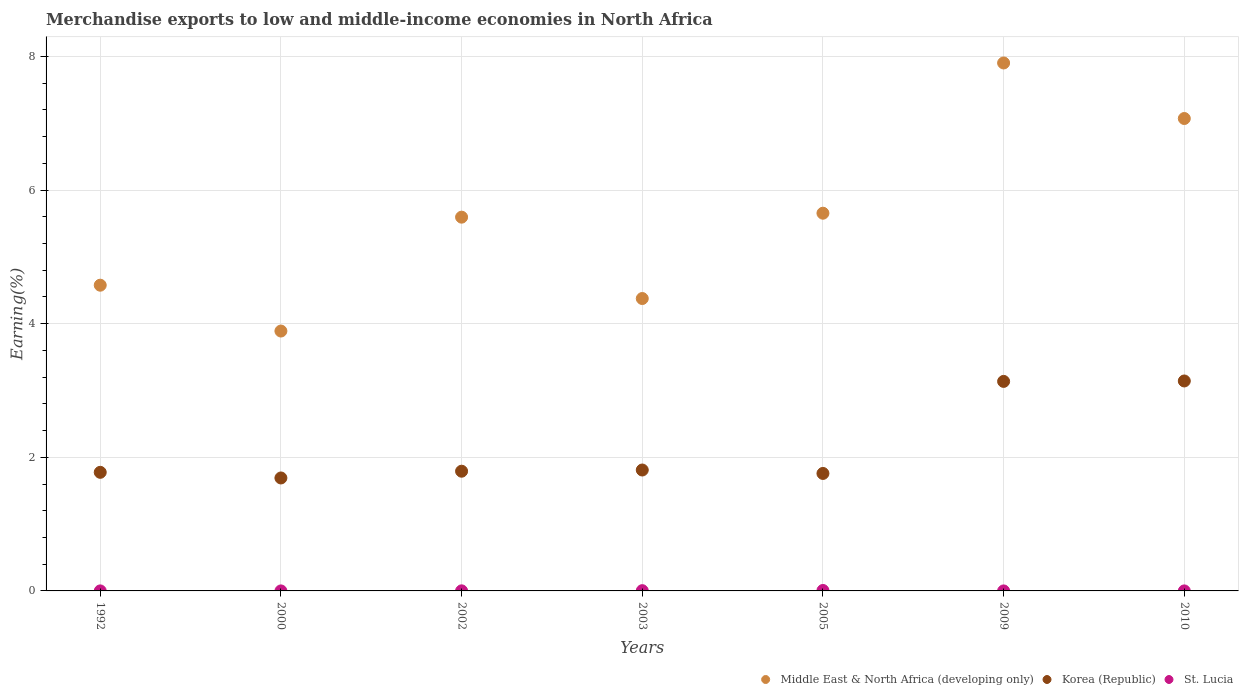What is the percentage of amount earned from merchandise exports in Korea (Republic) in 2005?
Provide a succinct answer. 1.76. Across all years, what is the maximum percentage of amount earned from merchandise exports in Middle East & North Africa (developing only)?
Provide a short and direct response. 7.9. Across all years, what is the minimum percentage of amount earned from merchandise exports in St. Lucia?
Your answer should be compact. 4.81975497009493e-5. In which year was the percentage of amount earned from merchandise exports in Korea (Republic) minimum?
Your answer should be compact. 2000. What is the total percentage of amount earned from merchandise exports in St. Lucia in the graph?
Keep it short and to the point. 0.01. What is the difference between the percentage of amount earned from merchandise exports in Korea (Republic) in 1992 and that in 2002?
Your answer should be compact. -0.02. What is the difference between the percentage of amount earned from merchandise exports in Korea (Republic) in 2002 and the percentage of amount earned from merchandise exports in Middle East & North Africa (developing only) in 2003?
Provide a succinct answer. -2.58. What is the average percentage of amount earned from merchandise exports in St. Lucia per year?
Keep it short and to the point. 0. In the year 2002, what is the difference between the percentage of amount earned from merchandise exports in St. Lucia and percentage of amount earned from merchandise exports in Korea (Republic)?
Your response must be concise. -1.79. What is the ratio of the percentage of amount earned from merchandise exports in Korea (Republic) in 2005 to that in 2009?
Offer a terse response. 0.56. Is the difference between the percentage of amount earned from merchandise exports in St. Lucia in 2003 and 2010 greater than the difference between the percentage of amount earned from merchandise exports in Korea (Republic) in 2003 and 2010?
Make the answer very short. Yes. What is the difference between the highest and the second highest percentage of amount earned from merchandise exports in Middle East & North Africa (developing only)?
Your answer should be compact. 0.83. What is the difference between the highest and the lowest percentage of amount earned from merchandise exports in Korea (Republic)?
Your answer should be very brief. 1.45. Is it the case that in every year, the sum of the percentage of amount earned from merchandise exports in Korea (Republic) and percentage of amount earned from merchandise exports in St. Lucia  is greater than the percentage of amount earned from merchandise exports in Middle East & North Africa (developing only)?
Keep it short and to the point. No. Does the percentage of amount earned from merchandise exports in St. Lucia monotonically increase over the years?
Your response must be concise. No. Is the percentage of amount earned from merchandise exports in Korea (Republic) strictly greater than the percentage of amount earned from merchandise exports in Middle East & North Africa (developing only) over the years?
Provide a succinct answer. No. How many dotlines are there?
Ensure brevity in your answer.  3. What is the difference between two consecutive major ticks on the Y-axis?
Your answer should be very brief. 2. Are the values on the major ticks of Y-axis written in scientific E-notation?
Give a very brief answer. No. What is the title of the graph?
Offer a very short reply. Merchandise exports to low and middle-income economies in North Africa. What is the label or title of the X-axis?
Make the answer very short. Years. What is the label or title of the Y-axis?
Your answer should be compact. Earning(%). What is the Earning(%) of Middle East & North Africa (developing only) in 1992?
Keep it short and to the point. 4.58. What is the Earning(%) in Korea (Republic) in 1992?
Your answer should be very brief. 1.78. What is the Earning(%) in St. Lucia in 1992?
Ensure brevity in your answer.  0. What is the Earning(%) in Middle East & North Africa (developing only) in 2000?
Make the answer very short. 3.89. What is the Earning(%) in Korea (Republic) in 2000?
Provide a short and direct response. 1.69. What is the Earning(%) of St. Lucia in 2000?
Keep it short and to the point. 0. What is the Earning(%) in Middle East & North Africa (developing only) in 2002?
Your answer should be compact. 5.59. What is the Earning(%) in Korea (Republic) in 2002?
Offer a very short reply. 1.79. What is the Earning(%) of St. Lucia in 2002?
Give a very brief answer. 0. What is the Earning(%) in Middle East & North Africa (developing only) in 2003?
Your answer should be compact. 4.38. What is the Earning(%) in Korea (Republic) in 2003?
Your answer should be compact. 1.81. What is the Earning(%) of St. Lucia in 2003?
Offer a very short reply. 0. What is the Earning(%) of Middle East & North Africa (developing only) in 2005?
Your answer should be compact. 5.65. What is the Earning(%) of Korea (Republic) in 2005?
Give a very brief answer. 1.76. What is the Earning(%) of St. Lucia in 2005?
Offer a terse response. 0.01. What is the Earning(%) of Middle East & North Africa (developing only) in 2009?
Your answer should be very brief. 7.9. What is the Earning(%) in Korea (Republic) in 2009?
Keep it short and to the point. 3.14. What is the Earning(%) in St. Lucia in 2009?
Offer a very short reply. 4.81975497009493e-5. What is the Earning(%) in Middle East & North Africa (developing only) in 2010?
Provide a short and direct response. 7.07. What is the Earning(%) of Korea (Republic) in 2010?
Your answer should be very brief. 3.14. What is the Earning(%) of St. Lucia in 2010?
Provide a succinct answer. 0. Across all years, what is the maximum Earning(%) in Middle East & North Africa (developing only)?
Make the answer very short. 7.9. Across all years, what is the maximum Earning(%) in Korea (Republic)?
Your answer should be compact. 3.14. Across all years, what is the maximum Earning(%) in St. Lucia?
Make the answer very short. 0.01. Across all years, what is the minimum Earning(%) of Middle East & North Africa (developing only)?
Provide a short and direct response. 3.89. Across all years, what is the minimum Earning(%) of Korea (Republic)?
Ensure brevity in your answer.  1.69. Across all years, what is the minimum Earning(%) of St. Lucia?
Provide a short and direct response. 4.81975497009493e-5. What is the total Earning(%) in Middle East & North Africa (developing only) in the graph?
Your response must be concise. 39.06. What is the total Earning(%) of Korea (Republic) in the graph?
Offer a very short reply. 15.1. What is the total Earning(%) of St. Lucia in the graph?
Your response must be concise. 0.01. What is the difference between the Earning(%) of Middle East & North Africa (developing only) in 1992 and that in 2000?
Keep it short and to the point. 0.69. What is the difference between the Earning(%) of Korea (Republic) in 1992 and that in 2000?
Provide a short and direct response. 0.08. What is the difference between the Earning(%) of Middle East & North Africa (developing only) in 1992 and that in 2002?
Your answer should be compact. -1.02. What is the difference between the Earning(%) of Korea (Republic) in 1992 and that in 2002?
Provide a succinct answer. -0.02. What is the difference between the Earning(%) in St. Lucia in 1992 and that in 2002?
Provide a short and direct response. -0. What is the difference between the Earning(%) of Middle East & North Africa (developing only) in 1992 and that in 2003?
Keep it short and to the point. 0.2. What is the difference between the Earning(%) in Korea (Republic) in 1992 and that in 2003?
Give a very brief answer. -0.03. What is the difference between the Earning(%) of St. Lucia in 1992 and that in 2003?
Your response must be concise. -0. What is the difference between the Earning(%) in Middle East & North Africa (developing only) in 1992 and that in 2005?
Your answer should be compact. -1.08. What is the difference between the Earning(%) in Korea (Republic) in 1992 and that in 2005?
Provide a short and direct response. 0.02. What is the difference between the Earning(%) in St. Lucia in 1992 and that in 2005?
Make the answer very short. -0.01. What is the difference between the Earning(%) of Middle East & North Africa (developing only) in 1992 and that in 2009?
Keep it short and to the point. -3.33. What is the difference between the Earning(%) in Korea (Republic) in 1992 and that in 2009?
Keep it short and to the point. -1.36. What is the difference between the Earning(%) of St. Lucia in 1992 and that in 2009?
Make the answer very short. 0. What is the difference between the Earning(%) in Middle East & North Africa (developing only) in 1992 and that in 2010?
Your answer should be compact. -2.5. What is the difference between the Earning(%) in Korea (Republic) in 1992 and that in 2010?
Your answer should be compact. -1.37. What is the difference between the Earning(%) in St. Lucia in 1992 and that in 2010?
Your answer should be very brief. 0. What is the difference between the Earning(%) of Middle East & North Africa (developing only) in 2000 and that in 2002?
Provide a short and direct response. -1.7. What is the difference between the Earning(%) in Korea (Republic) in 2000 and that in 2002?
Provide a short and direct response. -0.1. What is the difference between the Earning(%) of St. Lucia in 2000 and that in 2002?
Give a very brief answer. -0. What is the difference between the Earning(%) in Middle East & North Africa (developing only) in 2000 and that in 2003?
Offer a very short reply. -0.49. What is the difference between the Earning(%) in Korea (Republic) in 2000 and that in 2003?
Your answer should be very brief. -0.12. What is the difference between the Earning(%) in St. Lucia in 2000 and that in 2003?
Keep it short and to the point. -0. What is the difference between the Earning(%) of Middle East & North Africa (developing only) in 2000 and that in 2005?
Ensure brevity in your answer.  -1.76. What is the difference between the Earning(%) of Korea (Republic) in 2000 and that in 2005?
Provide a succinct answer. -0.07. What is the difference between the Earning(%) of St. Lucia in 2000 and that in 2005?
Your answer should be very brief. -0.01. What is the difference between the Earning(%) of Middle East & North Africa (developing only) in 2000 and that in 2009?
Give a very brief answer. -4.01. What is the difference between the Earning(%) in Korea (Republic) in 2000 and that in 2009?
Your answer should be very brief. -1.45. What is the difference between the Earning(%) of St. Lucia in 2000 and that in 2009?
Give a very brief answer. 0. What is the difference between the Earning(%) of Middle East & North Africa (developing only) in 2000 and that in 2010?
Offer a very short reply. -3.18. What is the difference between the Earning(%) of Korea (Republic) in 2000 and that in 2010?
Provide a succinct answer. -1.45. What is the difference between the Earning(%) of St. Lucia in 2000 and that in 2010?
Make the answer very short. -0. What is the difference between the Earning(%) in Middle East & North Africa (developing only) in 2002 and that in 2003?
Offer a terse response. 1.22. What is the difference between the Earning(%) in Korea (Republic) in 2002 and that in 2003?
Your answer should be very brief. -0.02. What is the difference between the Earning(%) in St. Lucia in 2002 and that in 2003?
Keep it short and to the point. -0. What is the difference between the Earning(%) in Middle East & North Africa (developing only) in 2002 and that in 2005?
Ensure brevity in your answer.  -0.06. What is the difference between the Earning(%) of Korea (Republic) in 2002 and that in 2005?
Your response must be concise. 0.03. What is the difference between the Earning(%) in St. Lucia in 2002 and that in 2005?
Your answer should be compact. -0.01. What is the difference between the Earning(%) of Middle East & North Africa (developing only) in 2002 and that in 2009?
Provide a succinct answer. -2.31. What is the difference between the Earning(%) in Korea (Republic) in 2002 and that in 2009?
Your response must be concise. -1.34. What is the difference between the Earning(%) of St. Lucia in 2002 and that in 2009?
Your answer should be very brief. 0. What is the difference between the Earning(%) in Middle East & North Africa (developing only) in 2002 and that in 2010?
Offer a terse response. -1.48. What is the difference between the Earning(%) of Korea (Republic) in 2002 and that in 2010?
Give a very brief answer. -1.35. What is the difference between the Earning(%) in Middle East & North Africa (developing only) in 2003 and that in 2005?
Provide a succinct answer. -1.28. What is the difference between the Earning(%) of Korea (Republic) in 2003 and that in 2005?
Provide a short and direct response. 0.05. What is the difference between the Earning(%) in St. Lucia in 2003 and that in 2005?
Your answer should be very brief. -0. What is the difference between the Earning(%) in Middle East & North Africa (developing only) in 2003 and that in 2009?
Provide a short and direct response. -3.53. What is the difference between the Earning(%) in Korea (Republic) in 2003 and that in 2009?
Provide a succinct answer. -1.33. What is the difference between the Earning(%) in St. Lucia in 2003 and that in 2009?
Provide a succinct answer. 0. What is the difference between the Earning(%) of Middle East & North Africa (developing only) in 2003 and that in 2010?
Offer a terse response. -2.69. What is the difference between the Earning(%) of Korea (Republic) in 2003 and that in 2010?
Your answer should be compact. -1.33. What is the difference between the Earning(%) of St. Lucia in 2003 and that in 2010?
Make the answer very short. 0. What is the difference between the Earning(%) in Middle East & North Africa (developing only) in 2005 and that in 2009?
Keep it short and to the point. -2.25. What is the difference between the Earning(%) in Korea (Republic) in 2005 and that in 2009?
Ensure brevity in your answer.  -1.38. What is the difference between the Earning(%) of St. Lucia in 2005 and that in 2009?
Give a very brief answer. 0.01. What is the difference between the Earning(%) in Middle East & North Africa (developing only) in 2005 and that in 2010?
Provide a short and direct response. -1.42. What is the difference between the Earning(%) in Korea (Republic) in 2005 and that in 2010?
Provide a succinct answer. -1.38. What is the difference between the Earning(%) of St. Lucia in 2005 and that in 2010?
Your answer should be compact. 0.01. What is the difference between the Earning(%) in Middle East & North Africa (developing only) in 2009 and that in 2010?
Ensure brevity in your answer.  0.83. What is the difference between the Earning(%) in Korea (Republic) in 2009 and that in 2010?
Your answer should be compact. -0.01. What is the difference between the Earning(%) in St. Lucia in 2009 and that in 2010?
Your answer should be very brief. -0. What is the difference between the Earning(%) of Middle East & North Africa (developing only) in 1992 and the Earning(%) of Korea (Republic) in 2000?
Your answer should be compact. 2.89. What is the difference between the Earning(%) in Middle East & North Africa (developing only) in 1992 and the Earning(%) in St. Lucia in 2000?
Provide a succinct answer. 4.58. What is the difference between the Earning(%) of Korea (Republic) in 1992 and the Earning(%) of St. Lucia in 2000?
Make the answer very short. 1.77. What is the difference between the Earning(%) in Middle East & North Africa (developing only) in 1992 and the Earning(%) in Korea (Republic) in 2002?
Provide a succinct answer. 2.78. What is the difference between the Earning(%) of Middle East & North Africa (developing only) in 1992 and the Earning(%) of St. Lucia in 2002?
Offer a very short reply. 4.57. What is the difference between the Earning(%) of Korea (Republic) in 1992 and the Earning(%) of St. Lucia in 2002?
Keep it short and to the point. 1.77. What is the difference between the Earning(%) of Middle East & North Africa (developing only) in 1992 and the Earning(%) of Korea (Republic) in 2003?
Provide a short and direct response. 2.77. What is the difference between the Earning(%) in Middle East & North Africa (developing only) in 1992 and the Earning(%) in St. Lucia in 2003?
Your answer should be very brief. 4.57. What is the difference between the Earning(%) of Korea (Republic) in 1992 and the Earning(%) of St. Lucia in 2003?
Make the answer very short. 1.77. What is the difference between the Earning(%) of Middle East & North Africa (developing only) in 1992 and the Earning(%) of Korea (Republic) in 2005?
Ensure brevity in your answer.  2.82. What is the difference between the Earning(%) in Middle East & North Africa (developing only) in 1992 and the Earning(%) in St. Lucia in 2005?
Provide a short and direct response. 4.57. What is the difference between the Earning(%) in Korea (Republic) in 1992 and the Earning(%) in St. Lucia in 2005?
Give a very brief answer. 1.77. What is the difference between the Earning(%) in Middle East & North Africa (developing only) in 1992 and the Earning(%) in Korea (Republic) in 2009?
Your answer should be very brief. 1.44. What is the difference between the Earning(%) of Middle East & North Africa (developing only) in 1992 and the Earning(%) of St. Lucia in 2009?
Provide a succinct answer. 4.58. What is the difference between the Earning(%) of Korea (Republic) in 1992 and the Earning(%) of St. Lucia in 2009?
Your response must be concise. 1.78. What is the difference between the Earning(%) of Middle East & North Africa (developing only) in 1992 and the Earning(%) of Korea (Republic) in 2010?
Offer a terse response. 1.43. What is the difference between the Earning(%) of Middle East & North Africa (developing only) in 1992 and the Earning(%) of St. Lucia in 2010?
Ensure brevity in your answer.  4.58. What is the difference between the Earning(%) in Korea (Republic) in 1992 and the Earning(%) in St. Lucia in 2010?
Your answer should be very brief. 1.77. What is the difference between the Earning(%) of Middle East & North Africa (developing only) in 2000 and the Earning(%) of Korea (Republic) in 2002?
Offer a very short reply. 2.1. What is the difference between the Earning(%) of Middle East & North Africa (developing only) in 2000 and the Earning(%) of St. Lucia in 2002?
Offer a very short reply. 3.89. What is the difference between the Earning(%) in Korea (Republic) in 2000 and the Earning(%) in St. Lucia in 2002?
Your response must be concise. 1.69. What is the difference between the Earning(%) in Middle East & North Africa (developing only) in 2000 and the Earning(%) in Korea (Republic) in 2003?
Your answer should be very brief. 2.08. What is the difference between the Earning(%) of Middle East & North Africa (developing only) in 2000 and the Earning(%) of St. Lucia in 2003?
Your answer should be compact. 3.89. What is the difference between the Earning(%) of Korea (Republic) in 2000 and the Earning(%) of St. Lucia in 2003?
Offer a very short reply. 1.69. What is the difference between the Earning(%) of Middle East & North Africa (developing only) in 2000 and the Earning(%) of Korea (Republic) in 2005?
Provide a short and direct response. 2.13. What is the difference between the Earning(%) in Middle East & North Africa (developing only) in 2000 and the Earning(%) in St. Lucia in 2005?
Make the answer very short. 3.88. What is the difference between the Earning(%) of Korea (Republic) in 2000 and the Earning(%) of St. Lucia in 2005?
Make the answer very short. 1.68. What is the difference between the Earning(%) in Middle East & North Africa (developing only) in 2000 and the Earning(%) in Korea (Republic) in 2009?
Make the answer very short. 0.75. What is the difference between the Earning(%) in Middle East & North Africa (developing only) in 2000 and the Earning(%) in St. Lucia in 2009?
Provide a succinct answer. 3.89. What is the difference between the Earning(%) in Korea (Republic) in 2000 and the Earning(%) in St. Lucia in 2009?
Make the answer very short. 1.69. What is the difference between the Earning(%) of Middle East & North Africa (developing only) in 2000 and the Earning(%) of Korea (Republic) in 2010?
Provide a succinct answer. 0.75. What is the difference between the Earning(%) in Middle East & North Africa (developing only) in 2000 and the Earning(%) in St. Lucia in 2010?
Offer a very short reply. 3.89. What is the difference between the Earning(%) in Korea (Republic) in 2000 and the Earning(%) in St. Lucia in 2010?
Provide a short and direct response. 1.69. What is the difference between the Earning(%) of Middle East & North Africa (developing only) in 2002 and the Earning(%) of Korea (Republic) in 2003?
Ensure brevity in your answer.  3.78. What is the difference between the Earning(%) in Middle East & North Africa (developing only) in 2002 and the Earning(%) in St. Lucia in 2003?
Ensure brevity in your answer.  5.59. What is the difference between the Earning(%) of Korea (Republic) in 2002 and the Earning(%) of St. Lucia in 2003?
Provide a short and direct response. 1.79. What is the difference between the Earning(%) of Middle East & North Africa (developing only) in 2002 and the Earning(%) of Korea (Republic) in 2005?
Your answer should be compact. 3.84. What is the difference between the Earning(%) in Middle East & North Africa (developing only) in 2002 and the Earning(%) in St. Lucia in 2005?
Offer a terse response. 5.59. What is the difference between the Earning(%) in Korea (Republic) in 2002 and the Earning(%) in St. Lucia in 2005?
Your answer should be compact. 1.79. What is the difference between the Earning(%) of Middle East & North Africa (developing only) in 2002 and the Earning(%) of Korea (Republic) in 2009?
Provide a short and direct response. 2.46. What is the difference between the Earning(%) in Middle East & North Africa (developing only) in 2002 and the Earning(%) in St. Lucia in 2009?
Keep it short and to the point. 5.59. What is the difference between the Earning(%) of Korea (Republic) in 2002 and the Earning(%) of St. Lucia in 2009?
Keep it short and to the point. 1.79. What is the difference between the Earning(%) in Middle East & North Africa (developing only) in 2002 and the Earning(%) in Korea (Republic) in 2010?
Ensure brevity in your answer.  2.45. What is the difference between the Earning(%) of Middle East & North Africa (developing only) in 2002 and the Earning(%) of St. Lucia in 2010?
Offer a terse response. 5.59. What is the difference between the Earning(%) of Korea (Republic) in 2002 and the Earning(%) of St. Lucia in 2010?
Your answer should be compact. 1.79. What is the difference between the Earning(%) of Middle East & North Africa (developing only) in 2003 and the Earning(%) of Korea (Republic) in 2005?
Your answer should be very brief. 2.62. What is the difference between the Earning(%) of Middle East & North Africa (developing only) in 2003 and the Earning(%) of St. Lucia in 2005?
Give a very brief answer. 4.37. What is the difference between the Earning(%) in Korea (Republic) in 2003 and the Earning(%) in St. Lucia in 2005?
Your answer should be very brief. 1.8. What is the difference between the Earning(%) of Middle East & North Africa (developing only) in 2003 and the Earning(%) of Korea (Republic) in 2009?
Your response must be concise. 1.24. What is the difference between the Earning(%) of Middle East & North Africa (developing only) in 2003 and the Earning(%) of St. Lucia in 2009?
Your answer should be compact. 4.38. What is the difference between the Earning(%) in Korea (Republic) in 2003 and the Earning(%) in St. Lucia in 2009?
Your answer should be compact. 1.81. What is the difference between the Earning(%) in Middle East & North Africa (developing only) in 2003 and the Earning(%) in Korea (Republic) in 2010?
Ensure brevity in your answer.  1.23. What is the difference between the Earning(%) of Middle East & North Africa (developing only) in 2003 and the Earning(%) of St. Lucia in 2010?
Offer a very short reply. 4.38. What is the difference between the Earning(%) in Korea (Republic) in 2003 and the Earning(%) in St. Lucia in 2010?
Your answer should be compact. 1.81. What is the difference between the Earning(%) in Middle East & North Africa (developing only) in 2005 and the Earning(%) in Korea (Republic) in 2009?
Ensure brevity in your answer.  2.52. What is the difference between the Earning(%) of Middle East & North Africa (developing only) in 2005 and the Earning(%) of St. Lucia in 2009?
Keep it short and to the point. 5.65. What is the difference between the Earning(%) of Korea (Republic) in 2005 and the Earning(%) of St. Lucia in 2009?
Give a very brief answer. 1.76. What is the difference between the Earning(%) in Middle East & North Africa (developing only) in 2005 and the Earning(%) in Korea (Republic) in 2010?
Offer a terse response. 2.51. What is the difference between the Earning(%) in Middle East & North Africa (developing only) in 2005 and the Earning(%) in St. Lucia in 2010?
Your response must be concise. 5.65. What is the difference between the Earning(%) in Korea (Republic) in 2005 and the Earning(%) in St. Lucia in 2010?
Offer a very short reply. 1.76. What is the difference between the Earning(%) of Middle East & North Africa (developing only) in 2009 and the Earning(%) of Korea (Republic) in 2010?
Your response must be concise. 4.76. What is the difference between the Earning(%) in Middle East & North Africa (developing only) in 2009 and the Earning(%) in St. Lucia in 2010?
Keep it short and to the point. 7.9. What is the difference between the Earning(%) of Korea (Republic) in 2009 and the Earning(%) of St. Lucia in 2010?
Offer a very short reply. 3.14. What is the average Earning(%) of Middle East & North Africa (developing only) per year?
Offer a very short reply. 5.58. What is the average Earning(%) of Korea (Republic) per year?
Your answer should be very brief. 2.16. What is the average Earning(%) of St. Lucia per year?
Keep it short and to the point. 0. In the year 1992, what is the difference between the Earning(%) of Middle East & North Africa (developing only) and Earning(%) of Korea (Republic)?
Offer a terse response. 2.8. In the year 1992, what is the difference between the Earning(%) in Middle East & North Africa (developing only) and Earning(%) in St. Lucia?
Keep it short and to the point. 4.58. In the year 1992, what is the difference between the Earning(%) in Korea (Republic) and Earning(%) in St. Lucia?
Ensure brevity in your answer.  1.77. In the year 2000, what is the difference between the Earning(%) in Middle East & North Africa (developing only) and Earning(%) in Korea (Republic)?
Your answer should be very brief. 2.2. In the year 2000, what is the difference between the Earning(%) in Middle East & North Africa (developing only) and Earning(%) in St. Lucia?
Make the answer very short. 3.89. In the year 2000, what is the difference between the Earning(%) in Korea (Republic) and Earning(%) in St. Lucia?
Offer a very short reply. 1.69. In the year 2002, what is the difference between the Earning(%) of Middle East & North Africa (developing only) and Earning(%) of Korea (Republic)?
Give a very brief answer. 3.8. In the year 2002, what is the difference between the Earning(%) of Middle East & North Africa (developing only) and Earning(%) of St. Lucia?
Your response must be concise. 5.59. In the year 2002, what is the difference between the Earning(%) in Korea (Republic) and Earning(%) in St. Lucia?
Your response must be concise. 1.79. In the year 2003, what is the difference between the Earning(%) in Middle East & North Africa (developing only) and Earning(%) in Korea (Republic)?
Provide a short and direct response. 2.57. In the year 2003, what is the difference between the Earning(%) in Middle East & North Africa (developing only) and Earning(%) in St. Lucia?
Your answer should be compact. 4.37. In the year 2003, what is the difference between the Earning(%) in Korea (Republic) and Earning(%) in St. Lucia?
Offer a very short reply. 1.81. In the year 2005, what is the difference between the Earning(%) in Middle East & North Africa (developing only) and Earning(%) in Korea (Republic)?
Keep it short and to the point. 3.9. In the year 2005, what is the difference between the Earning(%) in Middle East & North Africa (developing only) and Earning(%) in St. Lucia?
Your response must be concise. 5.65. In the year 2005, what is the difference between the Earning(%) of Korea (Republic) and Earning(%) of St. Lucia?
Keep it short and to the point. 1.75. In the year 2009, what is the difference between the Earning(%) of Middle East & North Africa (developing only) and Earning(%) of Korea (Republic)?
Offer a very short reply. 4.77. In the year 2009, what is the difference between the Earning(%) in Middle East & North Africa (developing only) and Earning(%) in St. Lucia?
Provide a succinct answer. 7.9. In the year 2009, what is the difference between the Earning(%) in Korea (Republic) and Earning(%) in St. Lucia?
Ensure brevity in your answer.  3.14. In the year 2010, what is the difference between the Earning(%) of Middle East & North Africa (developing only) and Earning(%) of Korea (Republic)?
Provide a short and direct response. 3.93. In the year 2010, what is the difference between the Earning(%) of Middle East & North Africa (developing only) and Earning(%) of St. Lucia?
Offer a very short reply. 7.07. In the year 2010, what is the difference between the Earning(%) in Korea (Republic) and Earning(%) in St. Lucia?
Your answer should be compact. 3.14. What is the ratio of the Earning(%) of Middle East & North Africa (developing only) in 1992 to that in 2000?
Your answer should be compact. 1.18. What is the ratio of the Earning(%) of Korea (Republic) in 1992 to that in 2000?
Provide a short and direct response. 1.05. What is the ratio of the Earning(%) of St. Lucia in 1992 to that in 2000?
Ensure brevity in your answer.  2.73. What is the ratio of the Earning(%) in Middle East & North Africa (developing only) in 1992 to that in 2002?
Make the answer very short. 0.82. What is the ratio of the Earning(%) in Korea (Republic) in 1992 to that in 2002?
Offer a terse response. 0.99. What is the ratio of the Earning(%) in St. Lucia in 1992 to that in 2002?
Keep it short and to the point. 0.36. What is the ratio of the Earning(%) of Middle East & North Africa (developing only) in 1992 to that in 2003?
Ensure brevity in your answer.  1.05. What is the ratio of the Earning(%) of Korea (Republic) in 1992 to that in 2003?
Give a very brief answer. 0.98. What is the ratio of the Earning(%) in St. Lucia in 1992 to that in 2003?
Keep it short and to the point. 0.12. What is the ratio of the Earning(%) in Middle East & North Africa (developing only) in 1992 to that in 2005?
Keep it short and to the point. 0.81. What is the ratio of the Earning(%) of Korea (Republic) in 1992 to that in 2005?
Offer a very short reply. 1.01. What is the ratio of the Earning(%) of St. Lucia in 1992 to that in 2005?
Offer a very short reply. 0.07. What is the ratio of the Earning(%) of Middle East & North Africa (developing only) in 1992 to that in 2009?
Provide a short and direct response. 0.58. What is the ratio of the Earning(%) of Korea (Republic) in 1992 to that in 2009?
Make the answer very short. 0.57. What is the ratio of the Earning(%) in St. Lucia in 1992 to that in 2009?
Provide a short and direct response. 9.29. What is the ratio of the Earning(%) in Middle East & North Africa (developing only) in 1992 to that in 2010?
Offer a terse response. 0.65. What is the ratio of the Earning(%) in Korea (Republic) in 1992 to that in 2010?
Offer a very short reply. 0.56. What is the ratio of the Earning(%) of St. Lucia in 1992 to that in 2010?
Provide a succinct answer. 1.85. What is the ratio of the Earning(%) in Middle East & North Africa (developing only) in 2000 to that in 2002?
Your answer should be compact. 0.7. What is the ratio of the Earning(%) of Korea (Republic) in 2000 to that in 2002?
Offer a very short reply. 0.94. What is the ratio of the Earning(%) in St. Lucia in 2000 to that in 2002?
Your answer should be very brief. 0.13. What is the ratio of the Earning(%) in Middle East & North Africa (developing only) in 2000 to that in 2003?
Your answer should be compact. 0.89. What is the ratio of the Earning(%) in Korea (Republic) in 2000 to that in 2003?
Give a very brief answer. 0.93. What is the ratio of the Earning(%) of St. Lucia in 2000 to that in 2003?
Keep it short and to the point. 0.04. What is the ratio of the Earning(%) of Middle East & North Africa (developing only) in 2000 to that in 2005?
Offer a terse response. 0.69. What is the ratio of the Earning(%) in Korea (Republic) in 2000 to that in 2005?
Your answer should be compact. 0.96. What is the ratio of the Earning(%) of St. Lucia in 2000 to that in 2005?
Keep it short and to the point. 0.02. What is the ratio of the Earning(%) of Middle East & North Africa (developing only) in 2000 to that in 2009?
Offer a terse response. 0.49. What is the ratio of the Earning(%) in Korea (Republic) in 2000 to that in 2009?
Offer a very short reply. 0.54. What is the ratio of the Earning(%) in St. Lucia in 2000 to that in 2009?
Offer a very short reply. 3.4. What is the ratio of the Earning(%) of Middle East & North Africa (developing only) in 2000 to that in 2010?
Make the answer very short. 0.55. What is the ratio of the Earning(%) of Korea (Republic) in 2000 to that in 2010?
Offer a very short reply. 0.54. What is the ratio of the Earning(%) of St. Lucia in 2000 to that in 2010?
Give a very brief answer. 0.68. What is the ratio of the Earning(%) in Middle East & North Africa (developing only) in 2002 to that in 2003?
Make the answer very short. 1.28. What is the ratio of the Earning(%) in St. Lucia in 2002 to that in 2003?
Offer a very short reply. 0.33. What is the ratio of the Earning(%) of Middle East & North Africa (developing only) in 2002 to that in 2005?
Ensure brevity in your answer.  0.99. What is the ratio of the Earning(%) of Korea (Republic) in 2002 to that in 2005?
Ensure brevity in your answer.  1.02. What is the ratio of the Earning(%) of St. Lucia in 2002 to that in 2005?
Make the answer very short. 0.19. What is the ratio of the Earning(%) in Middle East & North Africa (developing only) in 2002 to that in 2009?
Make the answer very short. 0.71. What is the ratio of the Earning(%) in St. Lucia in 2002 to that in 2009?
Your response must be concise. 25.89. What is the ratio of the Earning(%) of Middle East & North Africa (developing only) in 2002 to that in 2010?
Give a very brief answer. 0.79. What is the ratio of the Earning(%) of Korea (Republic) in 2002 to that in 2010?
Provide a succinct answer. 0.57. What is the ratio of the Earning(%) of St. Lucia in 2002 to that in 2010?
Make the answer very short. 5.15. What is the ratio of the Earning(%) in Middle East & North Africa (developing only) in 2003 to that in 2005?
Offer a terse response. 0.77. What is the ratio of the Earning(%) in Korea (Republic) in 2003 to that in 2005?
Offer a very short reply. 1.03. What is the ratio of the Earning(%) of St. Lucia in 2003 to that in 2005?
Your answer should be compact. 0.57. What is the ratio of the Earning(%) in Middle East & North Africa (developing only) in 2003 to that in 2009?
Keep it short and to the point. 0.55. What is the ratio of the Earning(%) in Korea (Republic) in 2003 to that in 2009?
Ensure brevity in your answer.  0.58. What is the ratio of the Earning(%) in St. Lucia in 2003 to that in 2009?
Give a very brief answer. 79.5. What is the ratio of the Earning(%) of Middle East & North Africa (developing only) in 2003 to that in 2010?
Offer a terse response. 0.62. What is the ratio of the Earning(%) in Korea (Republic) in 2003 to that in 2010?
Offer a terse response. 0.58. What is the ratio of the Earning(%) of St. Lucia in 2003 to that in 2010?
Provide a short and direct response. 15.83. What is the ratio of the Earning(%) in Middle East & North Africa (developing only) in 2005 to that in 2009?
Keep it short and to the point. 0.72. What is the ratio of the Earning(%) of Korea (Republic) in 2005 to that in 2009?
Your answer should be compact. 0.56. What is the ratio of the Earning(%) in St. Lucia in 2005 to that in 2009?
Provide a succinct answer. 139. What is the ratio of the Earning(%) in Middle East & North Africa (developing only) in 2005 to that in 2010?
Offer a very short reply. 0.8. What is the ratio of the Earning(%) of Korea (Republic) in 2005 to that in 2010?
Offer a terse response. 0.56. What is the ratio of the Earning(%) of St. Lucia in 2005 to that in 2010?
Keep it short and to the point. 27.67. What is the ratio of the Earning(%) in Middle East & North Africa (developing only) in 2009 to that in 2010?
Ensure brevity in your answer.  1.12. What is the ratio of the Earning(%) of St. Lucia in 2009 to that in 2010?
Ensure brevity in your answer.  0.2. What is the difference between the highest and the second highest Earning(%) of Middle East & North Africa (developing only)?
Ensure brevity in your answer.  0.83. What is the difference between the highest and the second highest Earning(%) in Korea (Republic)?
Keep it short and to the point. 0.01. What is the difference between the highest and the second highest Earning(%) of St. Lucia?
Your answer should be very brief. 0. What is the difference between the highest and the lowest Earning(%) of Middle East & North Africa (developing only)?
Offer a terse response. 4.01. What is the difference between the highest and the lowest Earning(%) of Korea (Republic)?
Make the answer very short. 1.45. What is the difference between the highest and the lowest Earning(%) in St. Lucia?
Offer a terse response. 0.01. 